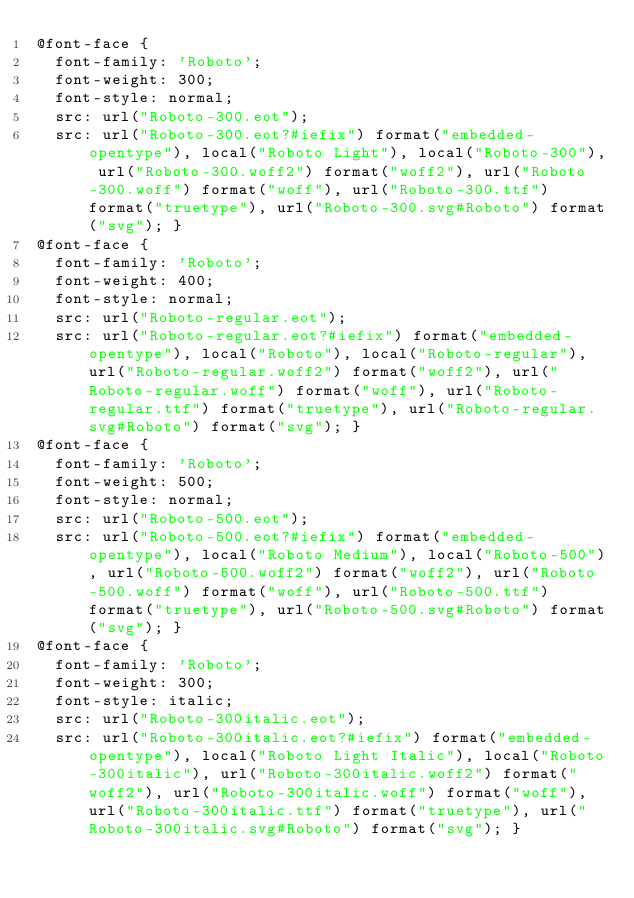<code> <loc_0><loc_0><loc_500><loc_500><_CSS_>@font-face {
  font-family: 'Roboto';
  font-weight: 300;
  font-style: normal;
  src: url("Roboto-300.eot");
  src: url("Roboto-300.eot?#iefix") format("embedded-opentype"), local("Roboto Light"), local("Roboto-300"), url("Roboto-300.woff2") format("woff2"), url("Roboto-300.woff") format("woff"), url("Roboto-300.ttf") format("truetype"), url("Roboto-300.svg#Roboto") format("svg"); }
@font-face {
  font-family: 'Roboto';
  font-weight: 400;
  font-style: normal;
  src: url("Roboto-regular.eot");
  src: url("Roboto-regular.eot?#iefix") format("embedded-opentype"), local("Roboto"), local("Roboto-regular"), url("Roboto-regular.woff2") format("woff2"), url("Roboto-regular.woff") format("woff"), url("Roboto-regular.ttf") format("truetype"), url("Roboto-regular.svg#Roboto") format("svg"); }
@font-face {
  font-family: 'Roboto';
  font-weight: 500;
  font-style: normal;
  src: url("Roboto-500.eot");
  src: url("Roboto-500.eot?#iefix") format("embedded-opentype"), local("Roboto Medium"), local("Roboto-500"), url("Roboto-500.woff2") format("woff2"), url("Roboto-500.woff") format("woff"), url("Roboto-500.ttf") format("truetype"), url("Roboto-500.svg#Roboto") format("svg"); }
@font-face {
  font-family: 'Roboto';
  font-weight: 300;
  font-style: italic;
  src: url("Roboto-300italic.eot");
  src: url("Roboto-300italic.eot?#iefix") format("embedded-opentype"), local("Roboto Light Italic"), local("Roboto-300italic"), url("Roboto-300italic.woff2") format("woff2"), url("Roboto-300italic.woff") format("woff"), url("Roboto-300italic.ttf") format("truetype"), url("Roboto-300italic.svg#Roboto") format("svg"); }
</code> 